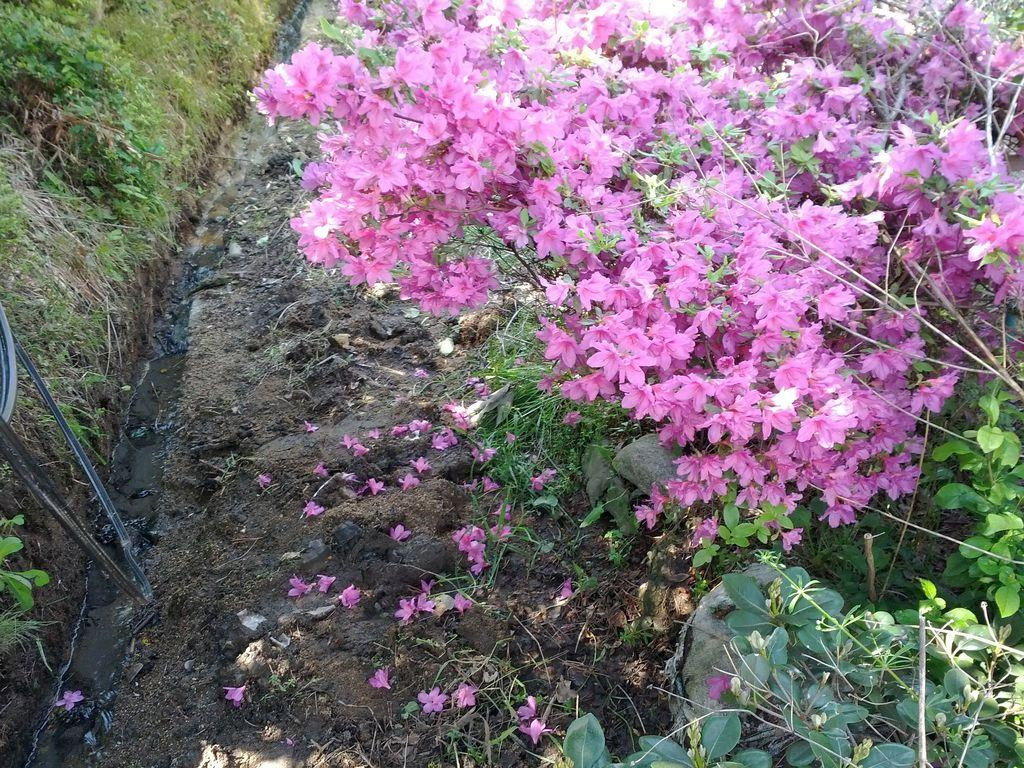What type of plants can be seen in the image? There are plants with flowers in the image. What other elements are present in the image besides plants? There are stones, grass, and water visible in the image. Can you describe the ground in the image? The ground is covered with grass. What is the unspecified object in the image? Unfortunately, the facts provided do not give any details about the unspecified object, so we cannot describe it. How many chairs are visible in the image? There are no chairs present in the image. What type of cube can be seen in the image? There is no cube present in the image. 